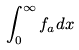Convert formula to latex. <formula><loc_0><loc_0><loc_500><loc_500>\int _ { 0 } ^ { \infty } f _ { a } d x</formula> 